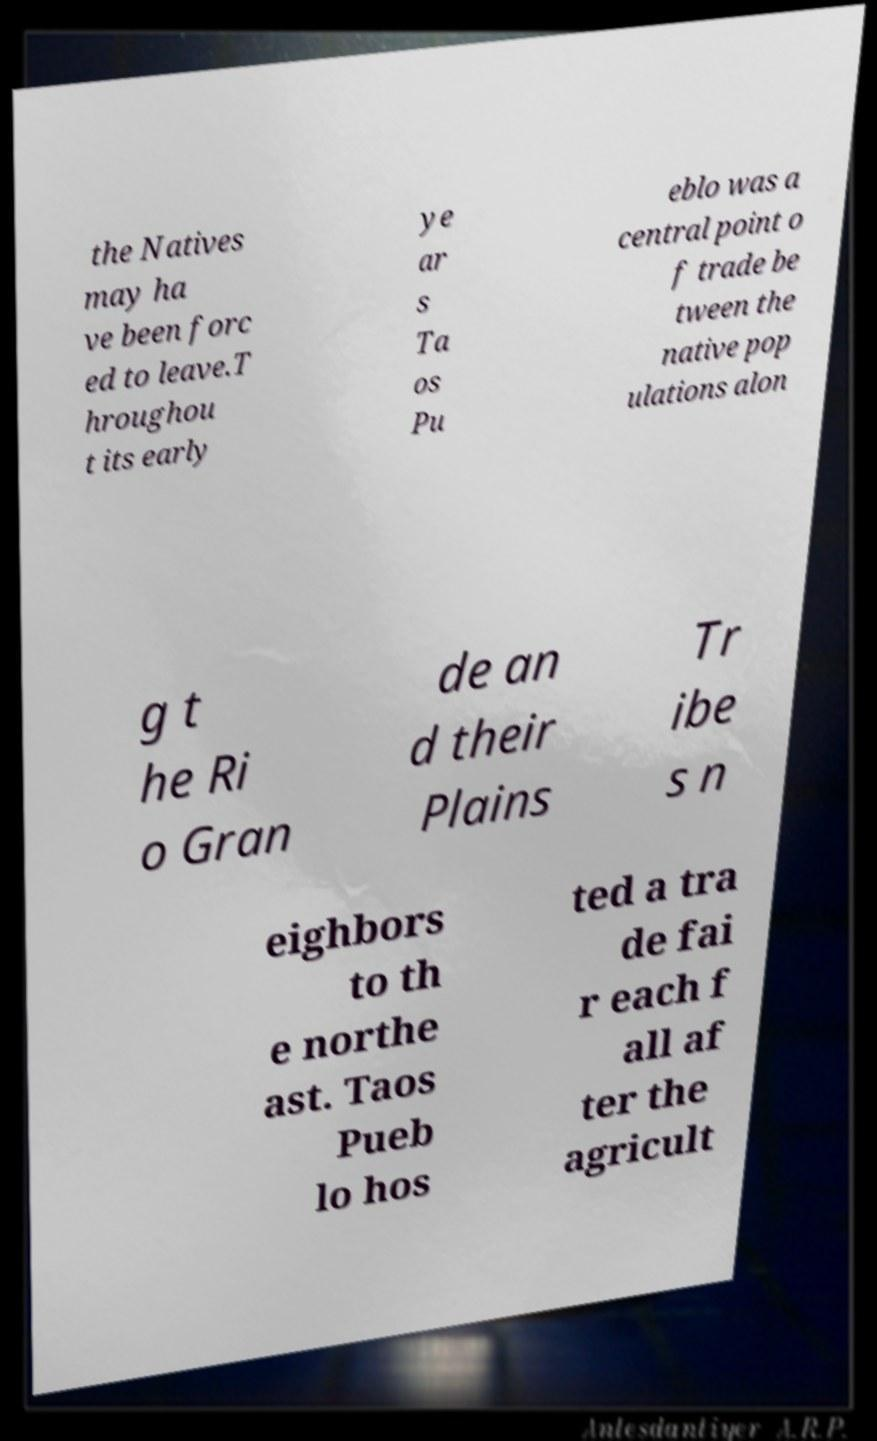Could you assist in decoding the text presented in this image and type it out clearly? the Natives may ha ve been forc ed to leave.T hroughou t its early ye ar s Ta os Pu eblo was a central point o f trade be tween the native pop ulations alon g t he Ri o Gran de an d their Plains Tr ibe s n eighbors to th e northe ast. Taos Pueb lo hos ted a tra de fai r each f all af ter the agricult 